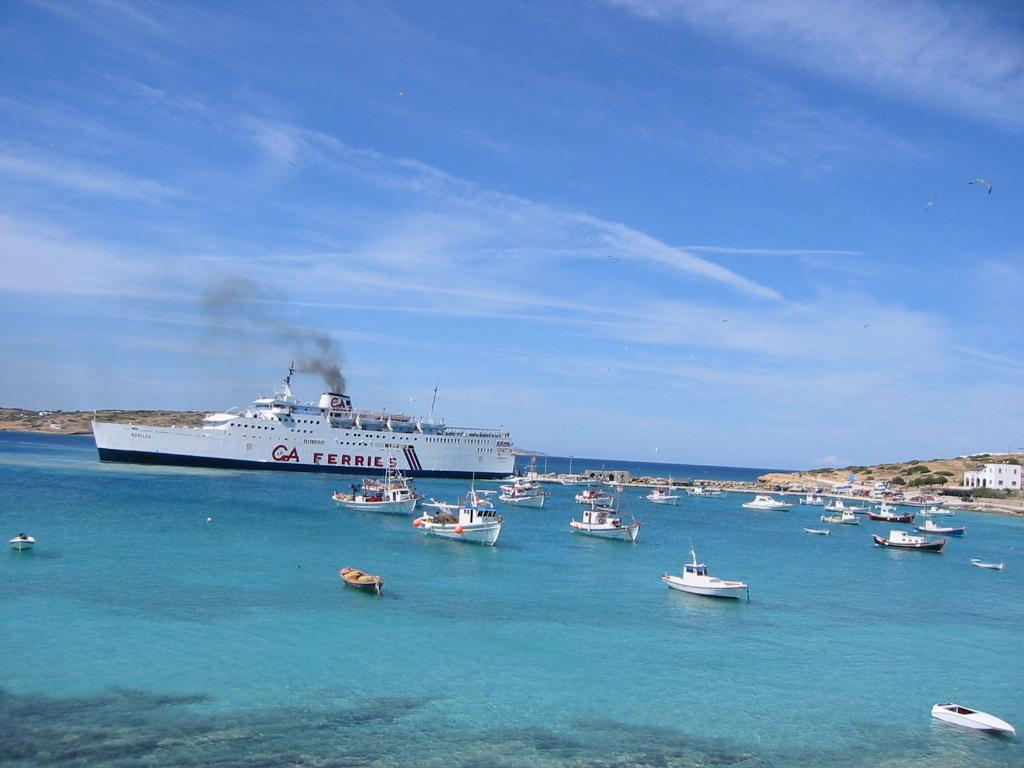What is happening in the water in the image? There are ships sailing in the water. What type of natural feature can be seen in the image? There are hills visible in the image. What type of vegetation is present in the image? There are plants in the image. Where is the building located in the image? The building is on the right side of the image. What is visible in the sky in the image? The sky is visible in the image. Can you see any eyes in the image? There are no eyes present in the image. What type of sound does the whistle make in the image? There is no whistle present in the image. 